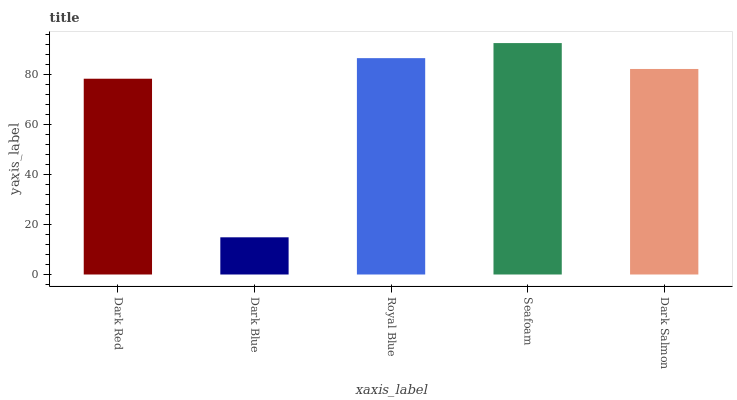Is Dark Blue the minimum?
Answer yes or no. Yes. Is Seafoam the maximum?
Answer yes or no. Yes. Is Royal Blue the minimum?
Answer yes or no. No. Is Royal Blue the maximum?
Answer yes or no. No. Is Royal Blue greater than Dark Blue?
Answer yes or no. Yes. Is Dark Blue less than Royal Blue?
Answer yes or no. Yes. Is Dark Blue greater than Royal Blue?
Answer yes or no. No. Is Royal Blue less than Dark Blue?
Answer yes or no. No. Is Dark Salmon the high median?
Answer yes or no. Yes. Is Dark Salmon the low median?
Answer yes or no. Yes. Is Seafoam the high median?
Answer yes or no. No. Is Royal Blue the low median?
Answer yes or no. No. 